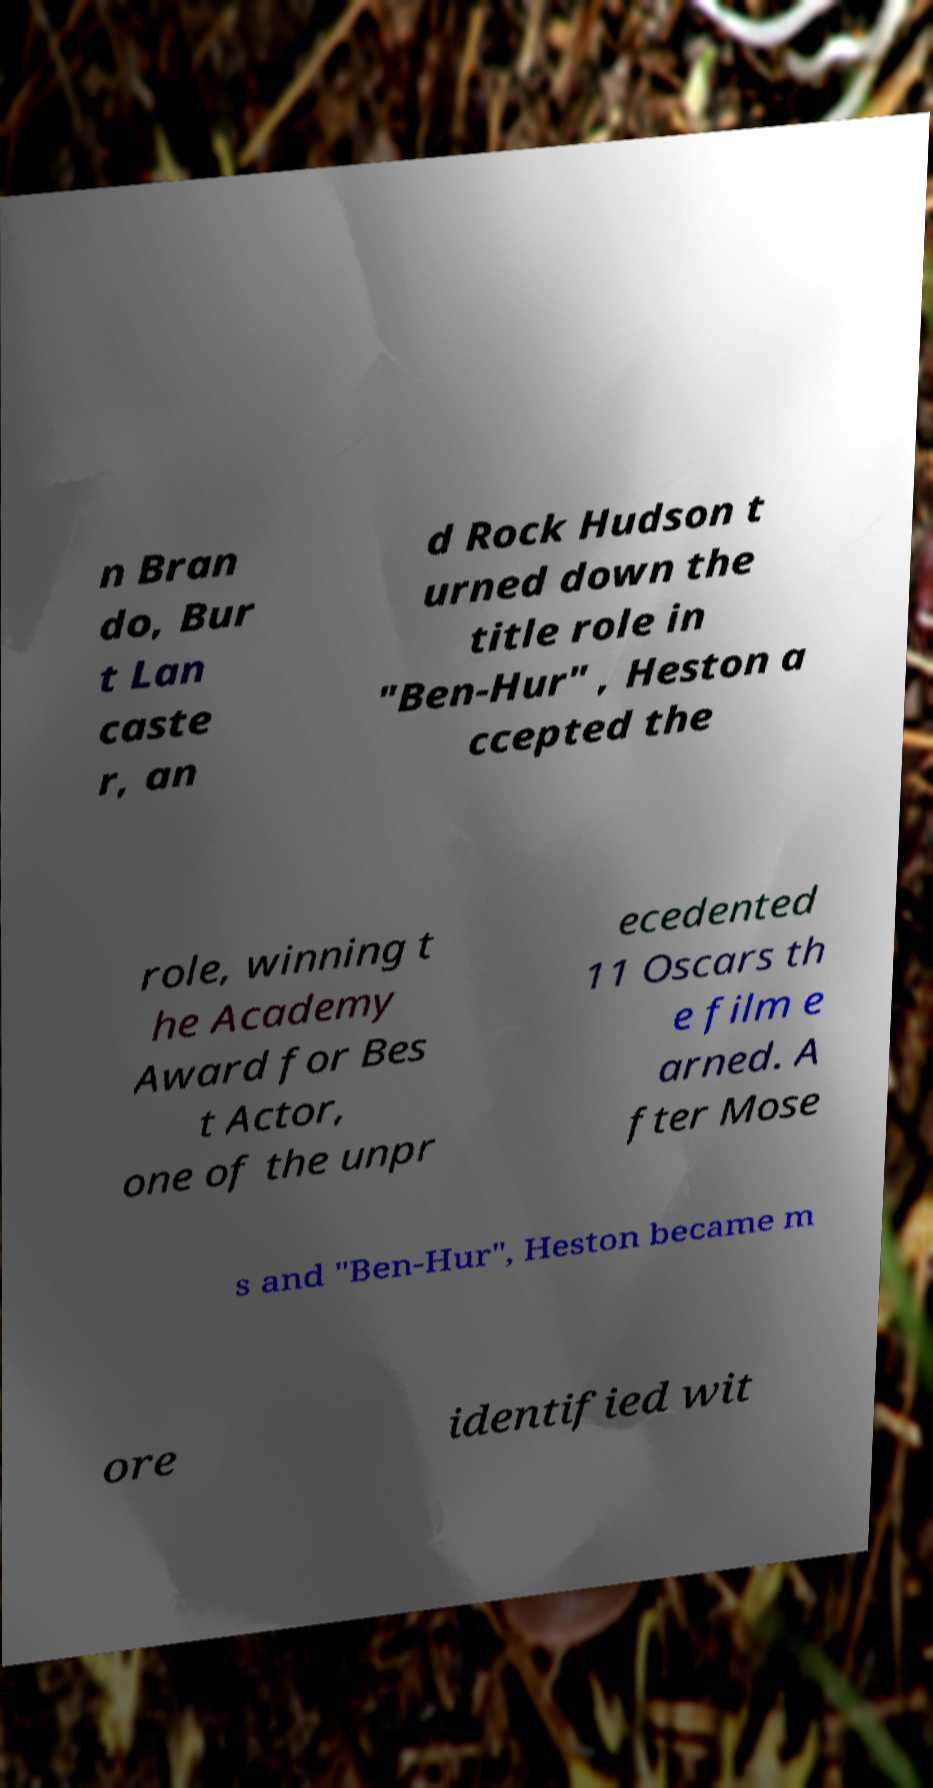I need the written content from this picture converted into text. Can you do that? n Bran do, Bur t Lan caste r, an d Rock Hudson t urned down the title role in "Ben-Hur" , Heston a ccepted the role, winning t he Academy Award for Bes t Actor, one of the unpr ecedented 11 Oscars th e film e arned. A fter Mose s and "Ben-Hur", Heston became m ore identified wit 